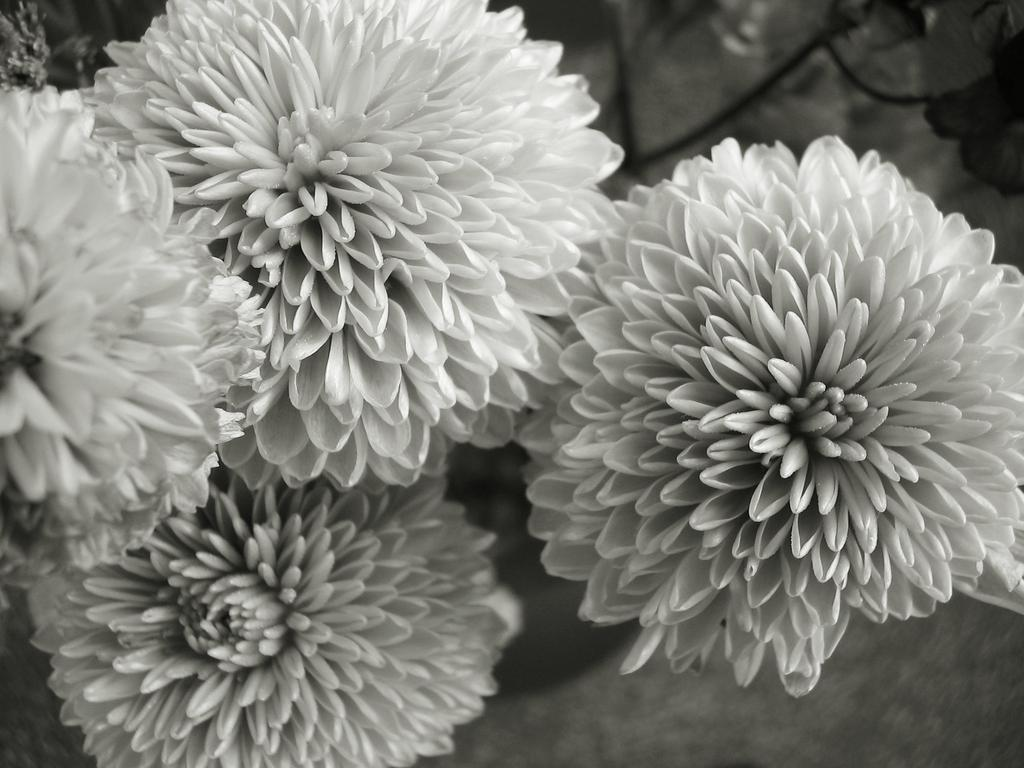What is the color scheme of the image? The image is black and white. What type of objects can be seen in the image? There are flowers in the image. Can you describe the color of the flowers? The flowers might be white in color. What is the background of the image? The background of the image is black. What type of trousers are visible in the image? There are no trousers present in the image; it features flowers and a black background. What type of plants can be seen growing in the image? The image only shows flowers, not plants growing in the ground. 